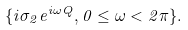<formula> <loc_0><loc_0><loc_500><loc_500>\{ i \sigma _ { 2 } e ^ { i \omega Q } , 0 \leq \omega < 2 \pi \} .</formula> 